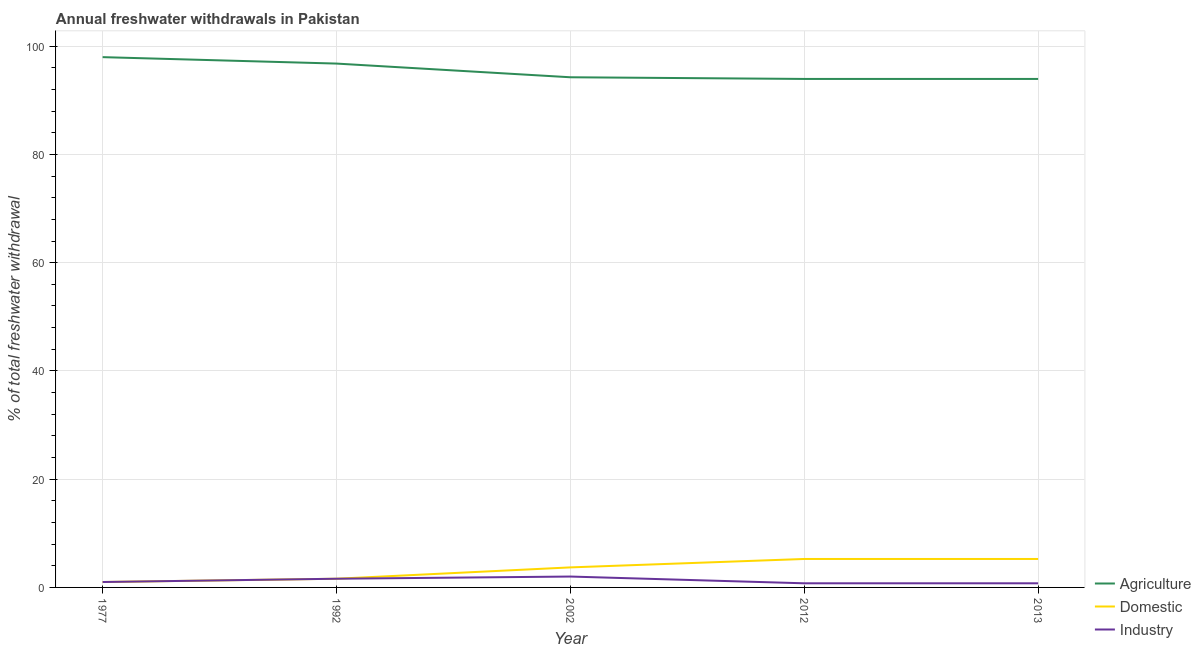Does the line corresponding to percentage of freshwater withdrawal for industry intersect with the line corresponding to percentage of freshwater withdrawal for domestic purposes?
Keep it short and to the point. Yes. What is the percentage of freshwater withdrawal for domestic purposes in 2012?
Keep it short and to the point. 5.26. Across all years, what is the maximum percentage of freshwater withdrawal for domestic purposes?
Your response must be concise. 5.26. Across all years, what is the minimum percentage of freshwater withdrawal for industry?
Offer a terse response. 0.76. What is the total percentage of freshwater withdrawal for agriculture in the graph?
Offer a terse response. 476.93. What is the difference between the percentage of freshwater withdrawal for agriculture in 1977 and that in 1992?
Provide a short and direct response. 1.19. What is the difference between the percentage of freshwater withdrawal for domestic purposes in 2013 and the percentage of freshwater withdrawal for industry in 1992?
Ensure brevity in your answer.  3.65. What is the average percentage of freshwater withdrawal for domestic purposes per year?
Your response must be concise. 3.37. In the year 2002, what is the difference between the percentage of freshwater withdrawal for industry and percentage of freshwater withdrawal for agriculture?
Make the answer very short. -92.25. In how many years, is the percentage of freshwater withdrawal for agriculture greater than 8 %?
Make the answer very short. 5. What is the ratio of the percentage of freshwater withdrawal for domestic purposes in 1977 to that in 1992?
Your answer should be very brief. 0.62. Is the percentage of freshwater withdrawal for industry in 1977 less than that in 2012?
Keep it short and to the point. No. What is the difference between the highest and the second highest percentage of freshwater withdrawal for domestic purposes?
Offer a terse response. 0. What is the difference between the highest and the lowest percentage of freshwater withdrawal for industry?
Make the answer very short. 1.25. Is the sum of the percentage of freshwater withdrawal for agriculture in 1992 and 2012 greater than the maximum percentage of freshwater withdrawal for industry across all years?
Provide a short and direct response. Yes. Is it the case that in every year, the sum of the percentage of freshwater withdrawal for agriculture and percentage of freshwater withdrawal for domestic purposes is greater than the percentage of freshwater withdrawal for industry?
Your answer should be compact. Yes. Does the percentage of freshwater withdrawal for domestic purposes monotonically increase over the years?
Provide a succinct answer. No. Is the percentage of freshwater withdrawal for domestic purposes strictly greater than the percentage of freshwater withdrawal for industry over the years?
Your response must be concise. No. How many lines are there?
Your answer should be very brief. 3. Are the values on the major ticks of Y-axis written in scientific E-notation?
Ensure brevity in your answer.  No. Does the graph contain any zero values?
Provide a succinct answer. No. Does the graph contain grids?
Your response must be concise. Yes. Where does the legend appear in the graph?
Offer a very short reply. Bottom right. How many legend labels are there?
Your answer should be very brief. 3. How are the legend labels stacked?
Give a very brief answer. Vertical. What is the title of the graph?
Your response must be concise. Annual freshwater withdrawals in Pakistan. Does "Unpaid family workers" appear as one of the legend labels in the graph?
Make the answer very short. No. What is the label or title of the X-axis?
Offer a terse response. Year. What is the label or title of the Y-axis?
Give a very brief answer. % of total freshwater withdrawal. What is the % of total freshwater withdrawal of Agriculture in 1977?
Make the answer very short. 97.98. What is the % of total freshwater withdrawal in Agriculture in 1992?
Offer a terse response. 96.79. What is the % of total freshwater withdrawal of Domestic in 1992?
Offer a very short reply. 1.61. What is the % of total freshwater withdrawal in Industry in 1992?
Make the answer very short. 1.61. What is the % of total freshwater withdrawal in Agriculture in 2002?
Provide a succinct answer. 94.26. What is the % of total freshwater withdrawal in Domestic in 2002?
Your answer should be compact. 3.7. What is the % of total freshwater withdrawal in Industry in 2002?
Offer a terse response. 2.01. What is the % of total freshwater withdrawal in Agriculture in 2012?
Keep it short and to the point. 93.95. What is the % of total freshwater withdrawal in Domestic in 2012?
Your response must be concise. 5.26. What is the % of total freshwater withdrawal of Industry in 2012?
Offer a very short reply. 0.76. What is the % of total freshwater withdrawal of Agriculture in 2013?
Offer a terse response. 93.95. What is the % of total freshwater withdrawal of Domestic in 2013?
Offer a very short reply. 5.26. What is the % of total freshwater withdrawal in Industry in 2013?
Make the answer very short. 0.76. Across all years, what is the maximum % of total freshwater withdrawal in Agriculture?
Ensure brevity in your answer.  97.98. Across all years, what is the maximum % of total freshwater withdrawal of Domestic?
Your answer should be compact. 5.26. Across all years, what is the maximum % of total freshwater withdrawal of Industry?
Your response must be concise. 2.01. Across all years, what is the minimum % of total freshwater withdrawal in Agriculture?
Make the answer very short. 93.95. Across all years, what is the minimum % of total freshwater withdrawal in Domestic?
Make the answer very short. 1. Across all years, what is the minimum % of total freshwater withdrawal in Industry?
Give a very brief answer. 0.76. What is the total % of total freshwater withdrawal in Agriculture in the graph?
Your answer should be compact. 476.93. What is the total % of total freshwater withdrawal of Domestic in the graph?
Your answer should be very brief. 16.83. What is the total % of total freshwater withdrawal in Industry in the graph?
Provide a succinct answer. 6.14. What is the difference between the % of total freshwater withdrawal of Agriculture in 1977 and that in 1992?
Provide a short and direct response. 1.19. What is the difference between the % of total freshwater withdrawal in Domestic in 1977 and that in 1992?
Your answer should be very brief. -0.61. What is the difference between the % of total freshwater withdrawal in Industry in 1977 and that in 1992?
Provide a short and direct response. -0.61. What is the difference between the % of total freshwater withdrawal of Agriculture in 1977 and that in 2002?
Provide a succinct answer. 3.72. What is the difference between the % of total freshwater withdrawal of Domestic in 1977 and that in 2002?
Give a very brief answer. -2.7. What is the difference between the % of total freshwater withdrawal in Industry in 1977 and that in 2002?
Give a very brief answer. -1.01. What is the difference between the % of total freshwater withdrawal of Agriculture in 1977 and that in 2012?
Provide a succinct answer. 4.03. What is the difference between the % of total freshwater withdrawal of Domestic in 1977 and that in 2012?
Keep it short and to the point. -4.26. What is the difference between the % of total freshwater withdrawal in Industry in 1977 and that in 2012?
Make the answer very short. 0.24. What is the difference between the % of total freshwater withdrawal of Agriculture in 1977 and that in 2013?
Your answer should be very brief. 4.03. What is the difference between the % of total freshwater withdrawal in Domestic in 1977 and that in 2013?
Your answer should be compact. -4.26. What is the difference between the % of total freshwater withdrawal in Industry in 1977 and that in 2013?
Ensure brevity in your answer.  0.24. What is the difference between the % of total freshwater withdrawal of Agriculture in 1992 and that in 2002?
Offer a very short reply. 2.53. What is the difference between the % of total freshwater withdrawal of Domestic in 1992 and that in 2002?
Your response must be concise. -2.1. What is the difference between the % of total freshwater withdrawal of Industry in 1992 and that in 2002?
Make the answer very short. -0.4. What is the difference between the % of total freshwater withdrawal of Agriculture in 1992 and that in 2012?
Provide a succinct answer. 2.84. What is the difference between the % of total freshwater withdrawal of Domestic in 1992 and that in 2012?
Ensure brevity in your answer.  -3.65. What is the difference between the % of total freshwater withdrawal in Industry in 1992 and that in 2012?
Offer a terse response. 0.84. What is the difference between the % of total freshwater withdrawal in Agriculture in 1992 and that in 2013?
Provide a short and direct response. 2.84. What is the difference between the % of total freshwater withdrawal in Domestic in 1992 and that in 2013?
Give a very brief answer. -3.65. What is the difference between the % of total freshwater withdrawal in Industry in 1992 and that in 2013?
Provide a succinct answer. 0.84. What is the difference between the % of total freshwater withdrawal in Agriculture in 2002 and that in 2012?
Offer a very short reply. 0.31. What is the difference between the % of total freshwater withdrawal of Domestic in 2002 and that in 2012?
Make the answer very short. -1.56. What is the difference between the % of total freshwater withdrawal of Industry in 2002 and that in 2012?
Provide a short and direct response. 1.25. What is the difference between the % of total freshwater withdrawal of Agriculture in 2002 and that in 2013?
Ensure brevity in your answer.  0.31. What is the difference between the % of total freshwater withdrawal in Domestic in 2002 and that in 2013?
Provide a succinct answer. -1.56. What is the difference between the % of total freshwater withdrawal of Industry in 2002 and that in 2013?
Keep it short and to the point. 1.25. What is the difference between the % of total freshwater withdrawal in Industry in 2012 and that in 2013?
Offer a terse response. 0. What is the difference between the % of total freshwater withdrawal of Agriculture in 1977 and the % of total freshwater withdrawal of Domestic in 1992?
Offer a very short reply. 96.37. What is the difference between the % of total freshwater withdrawal of Agriculture in 1977 and the % of total freshwater withdrawal of Industry in 1992?
Your response must be concise. 96.37. What is the difference between the % of total freshwater withdrawal of Domestic in 1977 and the % of total freshwater withdrawal of Industry in 1992?
Your response must be concise. -0.61. What is the difference between the % of total freshwater withdrawal in Agriculture in 1977 and the % of total freshwater withdrawal in Domestic in 2002?
Provide a short and direct response. 94.28. What is the difference between the % of total freshwater withdrawal in Agriculture in 1977 and the % of total freshwater withdrawal in Industry in 2002?
Provide a short and direct response. 95.97. What is the difference between the % of total freshwater withdrawal in Domestic in 1977 and the % of total freshwater withdrawal in Industry in 2002?
Your answer should be very brief. -1.01. What is the difference between the % of total freshwater withdrawal of Agriculture in 1977 and the % of total freshwater withdrawal of Domestic in 2012?
Offer a very short reply. 92.72. What is the difference between the % of total freshwater withdrawal of Agriculture in 1977 and the % of total freshwater withdrawal of Industry in 2012?
Your answer should be compact. 97.22. What is the difference between the % of total freshwater withdrawal in Domestic in 1977 and the % of total freshwater withdrawal in Industry in 2012?
Offer a very short reply. 0.24. What is the difference between the % of total freshwater withdrawal in Agriculture in 1977 and the % of total freshwater withdrawal in Domestic in 2013?
Offer a terse response. 92.72. What is the difference between the % of total freshwater withdrawal of Agriculture in 1977 and the % of total freshwater withdrawal of Industry in 2013?
Offer a very short reply. 97.22. What is the difference between the % of total freshwater withdrawal of Domestic in 1977 and the % of total freshwater withdrawal of Industry in 2013?
Give a very brief answer. 0.24. What is the difference between the % of total freshwater withdrawal of Agriculture in 1992 and the % of total freshwater withdrawal of Domestic in 2002?
Your answer should be compact. 93.09. What is the difference between the % of total freshwater withdrawal in Agriculture in 1992 and the % of total freshwater withdrawal in Industry in 2002?
Make the answer very short. 94.78. What is the difference between the % of total freshwater withdrawal in Domestic in 1992 and the % of total freshwater withdrawal in Industry in 2002?
Offer a terse response. -0.4. What is the difference between the % of total freshwater withdrawal of Agriculture in 1992 and the % of total freshwater withdrawal of Domestic in 2012?
Provide a short and direct response. 91.53. What is the difference between the % of total freshwater withdrawal of Agriculture in 1992 and the % of total freshwater withdrawal of Industry in 2012?
Keep it short and to the point. 96.03. What is the difference between the % of total freshwater withdrawal in Domestic in 1992 and the % of total freshwater withdrawal in Industry in 2012?
Provide a succinct answer. 0.84. What is the difference between the % of total freshwater withdrawal in Agriculture in 1992 and the % of total freshwater withdrawal in Domestic in 2013?
Ensure brevity in your answer.  91.53. What is the difference between the % of total freshwater withdrawal of Agriculture in 1992 and the % of total freshwater withdrawal of Industry in 2013?
Your answer should be compact. 96.03. What is the difference between the % of total freshwater withdrawal of Domestic in 1992 and the % of total freshwater withdrawal of Industry in 2013?
Provide a succinct answer. 0.84. What is the difference between the % of total freshwater withdrawal in Agriculture in 2002 and the % of total freshwater withdrawal in Domestic in 2012?
Provide a short and direct response. 89. What is the difference between the % of total freshwater withdrawal of Agriculture in 2002 and the % of total freshwater withdrawal of Industry in 2012?
Provide a succinct answer. 93.5. What is the difference between the % of total freshwater withdrawal of Domestic in 2002 and the % of total freshwater withdrawal of Industry in 2012?
Your response must be concise. 2.94. What is the difference between the % of total freshwater withdrawal of Agriculture in 2002 and the % of total freshwater withdrawal of Domestic in 2013?
Your response must be concise. 89. What is the difference between the % of total freshwater withdrawal of Agriculture in 2002 and the % of total freshwater withdrawal of Industry in 2013?
Offer a terse response. 93.5. What is the difference between the % of total freshwater withdrawal in Domestic in 2002 and the % of total freshwater withdrawal in Industry in 2013?
Provide a short and direct response. 2.94. What is the difference between the % of total freshwater withdrawal of Agriculture in 2012 and the % of total freshwater withdrawal of Domestic in 2013?
Offer a terse response. 88.69. What is the difference between the % of total freshwater withdrawal in Agriculture in 2012 and the % of total freshwater withdrawal in Industry in 2013?
Provide a succinct answer. 93.19. What is the difference between the % of total freshwater withdrawal of Domestic in 2012 and the % of total freshwater withdrawal of Industry in 2013?
Offer a very short reply. 4.5. What is the average % of total freshwater withdrawal in Agriculture per year?
Offer a very short reply. 95.39. What is the average % of total freshwater withdrawal in Domestic per year?
Make the answer very short. 3.37. What is the average % of total freshwater withdrawal in Industry per year?
Make the answer very short. 1.23. In the year 1977, what is the difference between the % of total freshwater withdrawal in Agriculture and % of total freshwater withdrawal in Domestic?
Ensure brevity in your answer.  96.98. In the year 1977, what is the difference between the % of total freshwater withdrawal of Agriculture and % of total freshwater withdrawal of Industry?
Offer a terse response. 96.98. In the year 1977, what is the difference between the % of total freshwater withdrawal of Domestic and % of total freshwater withdrawal of Industry?
Make the answer very short. 0. In the year 1992, what is the difference between the % of total freshwater withdrawal in Agriculture and % of total freshwater withdrawal in Domestic?
Keep it short and to the point. 95.18. In the year 1992, what is the difference between the % of total freshwater withdrawal of Agriculture and % of total freshwater withdrawal of Industry?
Provide a succinct answer. 95.18. In the year 2002, what is the difference between the % of total freshwater withdrawal in Agriculture and % of total freshwater withdrawal in Domestic?
Your response must be concise. 90.56. In the year 2002, what is the difference between the % of total freshwater withdrawal of Agriculture and % of total freshwater withdrawal of Industry?
Give a very brief answer. 92.25. In the year 2002, what is the difference between the % of total freshwater withdrawal in Domestic and % of total freshwater withdrawal in Industry?
Provide a short and direct response. 1.69. In the year 2012, what is the difference between the % of total freshwater withdrawal in Agriculture and % of total freshwater withdrawal in Domestic?
Give a very brief answer. 88.69. In the year 2012, what is the difference between the % of total freshwater withdrawal in Agriculture and % of total freshwater withdrawal in Industry?
Ensure brevity in your answer.  93.19. In the year 2012, what is the difference between the % of total freshwater withdrawal in Domestic and % of total freshwater withdrawal in Industry?
Ensure brevity in your answer.  4.5. In the year 2013, what is the difference between the % of total freshwater withdrawal in Agriculture and % of total freshwater withdrawal in Domestic?
Provide a short and direct response. 88.69. In the year 2013, what is the difference between the % of total freshwater withdrawal in Agriculture and % of total freshwater withdrawal in Industry?
Keep it short and to the point. 93.19. In the year 2013, what is the difference between the % of total freshwater withdrawal of Domestic and % of total freshwater withdrawal of Industry?
Your answer should be compact. 4.5. What is the ratio of the % of total freshwater withdrawal of Agriculture in 1977 to that in 1992?
Your answer should be very brief. 1.01. What is the ratio of the % of total freshwater withdrawal of Domestic in 1977 to that in 1992?
Provide a succinct answer. 0.62. What is the ratio of the % of total freshwater withdrawal in Industry in 1977 to that in 1992?
Your answer should be very brief. 0.62. What is the ratio of the % of total freshwater withdrawal of Agriculture in 1977 to that in 2002?
Offer a terse response. 1.04. What is the ratio of the % of total freshwater withdrawal in Domestic in 1977 to that in 2002?
Provide a succinct answer. 0.27. What is the ratio of the % of total freshwater withdrawal of Industry in 1977 to that in 2002?
Your answer should be very brief. 0.5. What is the ratio of the % of total freshwater withdrawal of Agriculture in 1977 to that in 2012?
Make the answer very short. 1.04. What is the ratio of the % of total freshwater withdrawal in Domestic in 1977 to that in 2012?
Give a very brief answer. 0.19. What is the ratio of the % of total freshwater withdrawal in Industry in 1977 to that in 2012?
Provide a succinct answer. 1.31. What is the ratio of the % of total freshwater withdrawal of Agriculture in 1977 to that in 2013?
Ensure brevity in your answer.  1.04. What is the ratio of the % of total freshwater withdrawal in Domestic in 1977 to that in 2013?
Provide a short and direct response. 0.19. What is the ratio of the % of total freshwater withdrawal in Industry in 1977 to that in 2013?
Keep it short and to the point. 1.31. What is the ratio of the % of total freshwater withdrawal of Agriculture in 1992 to that in 2002?
Your answer should be compact. 1.03. What is the ratio of the % of total freshwater withdrawal of Domestic in 1992 to that in 2002?
Your answer should be compact. 0.43. What is the ratio of the % of total freshwater withdrawal in Industry in 1992 to that in 2002?
Your answer should be compact. 0.8. What is the ratio of the % of total freshwater withdrawal of Agriculture in 1992 to that in 2012?
Provide a short and direct response. 1.03. What is the ratio of the % of total freshwater withdrawal in Domestic in 1992 to that in 2012?
Your answer should be very brief. 0.31. What is the ratio of the % of total freshwater withdrawal of Industry in 1992 to that in 2012?
Give a very brief answer. 2.11. What is the ratio of the % of total freshwater withdrawal in Agriculture in 1992 to that in 2013?
Give a very brief answer. 1.03. What is the ratio of the % of total freshwater withdrawal in Domestic in 1992 to that in 2013?
Offer a very short reply. 0.31. What is the ratio of the % of total freshwater withdrawal of Industry in 1992 to that in 2013?
Keep it short and to the point. 2.11. What is the ratio of the % of total freshwater withdrawal in Agriculture in 2002 to that in 2012?
Provide a short and direct response. 1. What is the ratio of the % of total freshwater withdrawal in Domestic in 2002 to that in 2012?
Offer a terse response. 0.7. What is the ratio of the % of total freshwater withdrawal of Industry in 2002 to that in 2012?
Give a very brief answer. 2.63. What is the ratio of the % of total freshwater withdrawal in Domestic in 2002 to that in 2013?
Offer a terse response. 0.7. What is the ratio of the % of total freshwater withdrawal in Industry in 2002 to that in 2013?
Provide a succinct answer. 2.63. What is the ratio of the % of total freshwater withdrawal of Domestic in 2012 to that in 2013?
Provide a succinct answer. 1. What is the ratio of the % of total freshwater withdrawal in Industry in 2012 to that in 2013?
Your response must be concise. 1. What is the difference between the highest and the second highest % of total freshwater withdrawal in Agriculture?
Give a very brief answer. 1.19. What is the difference between the highest and the second highest % of total freshwater withdrawal of Industry?
Give a very brief answer. 0.4. What is the difference between the highest and the lowest % of total freshwater withdrawal of Agriculture?
Provide a short and direct response. 4.03. What is the difference between the highest and the lowest % of total freshwater withdrawal in Domestic?
Give a very brief answer. 4.26. What is the difference between the highest and the lowest % of total freshwater withdrawal of Industry?
Provide a succinct answer. 1.25. 